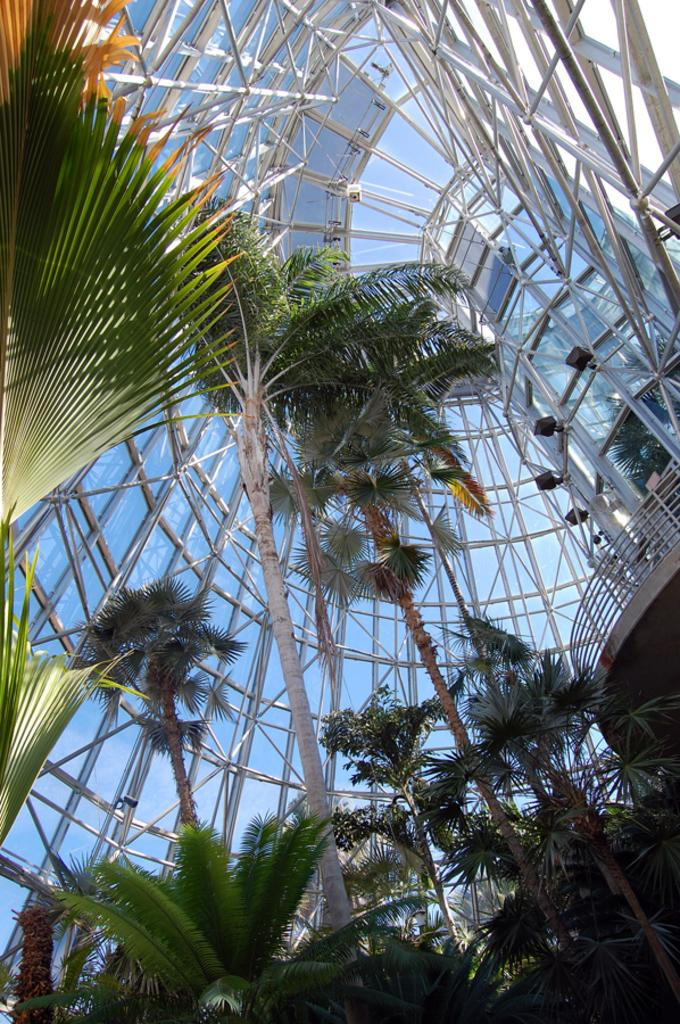What type of natural elements can be seen in the image? There are trees in the image. What type of man-made structures can be seen in the image? There are buildings in the image. What is visible at the top of the image? The sky is visible at the top of the image. What type of toys can be seen floating in space in the image? There is no reference to toys or space in the image; it features trees and buildings with a visible sky. 